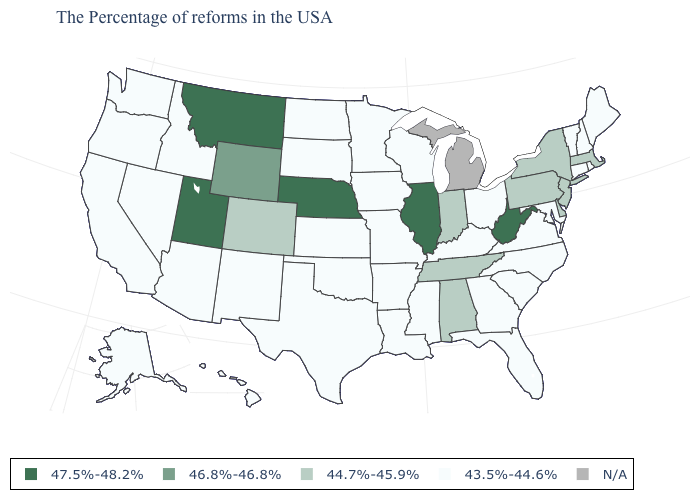Which states have the lowest value in the USA?
Write a very short answer. Maine, Rhode Island, New Hampshire, Vermont, Connecticut, Maryland, Virginia, North Carolina, South Carolina, Ohio, Florida, Georgia, Kentucky, Wisconsin, Mississippi, Louisiana, Missouri, Arkansas, Minnesota, Iowa, Kansas, Oklahoma, Texas, South Dakota, North Dakota, New Mexico, Arizona, Idaho, Nevada, California, Washington, Oregon, Alaska, Hawaii. Among the states that border New Hampshire , which have the highest value?
Keep it brief. Massachusetts. Among the states that border South Dakota , does Nebraska have the highest value?
Give a very brief answer. Yes. Which states hav the highest value in the MidWest?
Give a very brief answer. Illinois, Nebraska. Does Pennsylvania have the highest value in the Northeast?
Answer briefly. Yes. What is the value of Massachusetts?
Quick response, please. 44.7%-45.9%. What is the value of Mississippi?
Short answer required. 43.5%-44.6%. What is the value of Ohio?
Write a very short answer. 43.5%-44.6%. How many symbols are there in the legend?
Keep it brief. 5. Name the states that have a value in the range 46.8%-46.8%?
Answer briefly. Wyoming. Which states have the lowest value in the USA?
Write a very short answer. Maine, Rhode Island, New Hampshire, Vermont, Connecticut, Maryland, Virginia, North Carolina, South Carolina, Ohio, Florida, Georgia, Kentucky, Wisconsin, Mississippi, Louisiana, Missouri, Arkansas, Minnesota, Iowa, Kansas, Oklahoma, Texas, South Dakota, North Dakota, New Mexico, Arizona, Idaho, Nevada, California, Washington, Oregon, Alaska, Hawaii. What is the value of North Carolina?
Write a very short answer. 43.5%-44.6%. What is the lowest value in the USA?
Be succinct. 43.5%-44.6%. Name the states that have a value in the range 47.5%-48.2%?
Concise answer only. West Virginia, Illinois, Nebraska, Utah, Montana. 